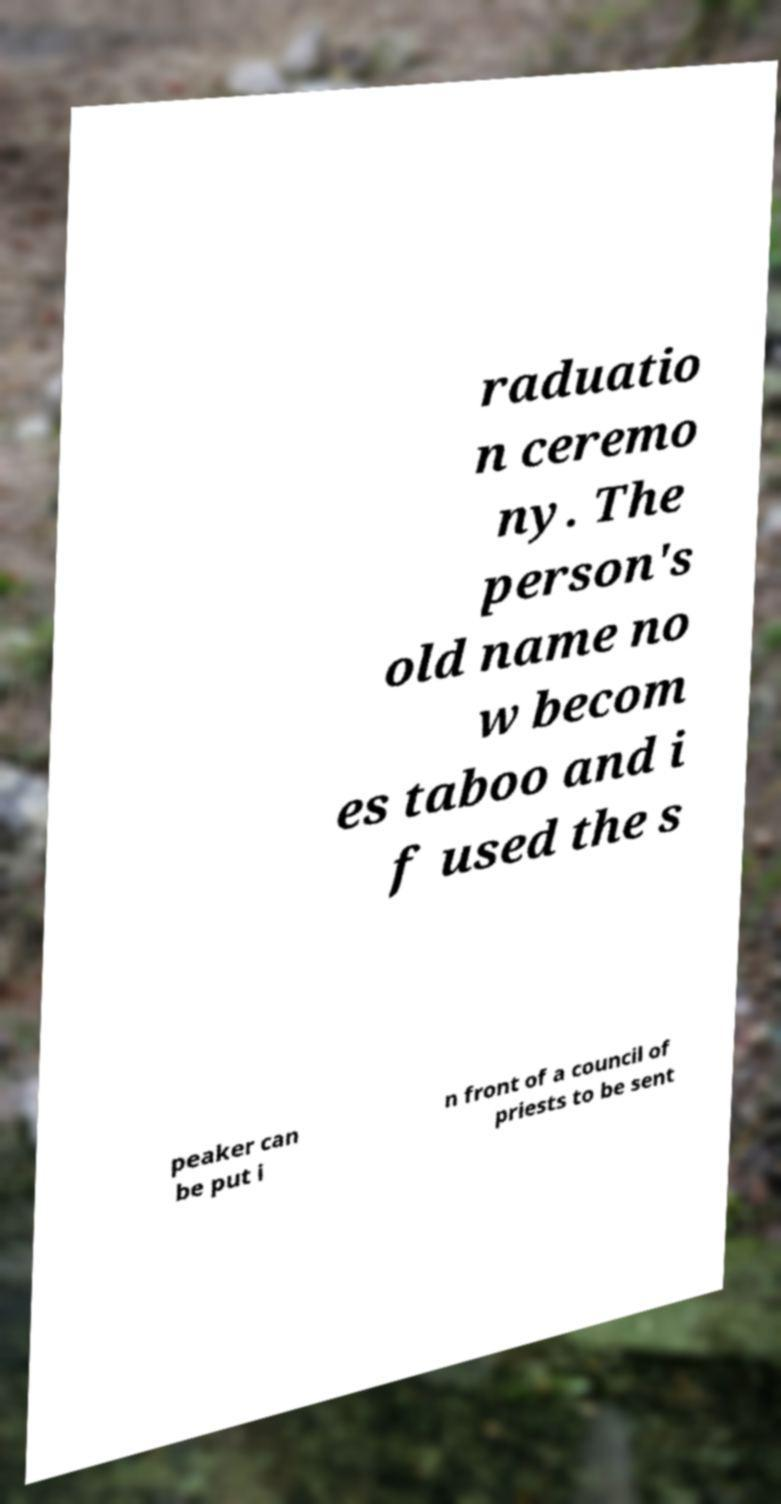I need the written content from this picture converted into text. Can you do that? raduatio n ceremo ny. The person's old name no w becom es taboo and i f used the s peaker can be put i n front of a council of priests to be sent 